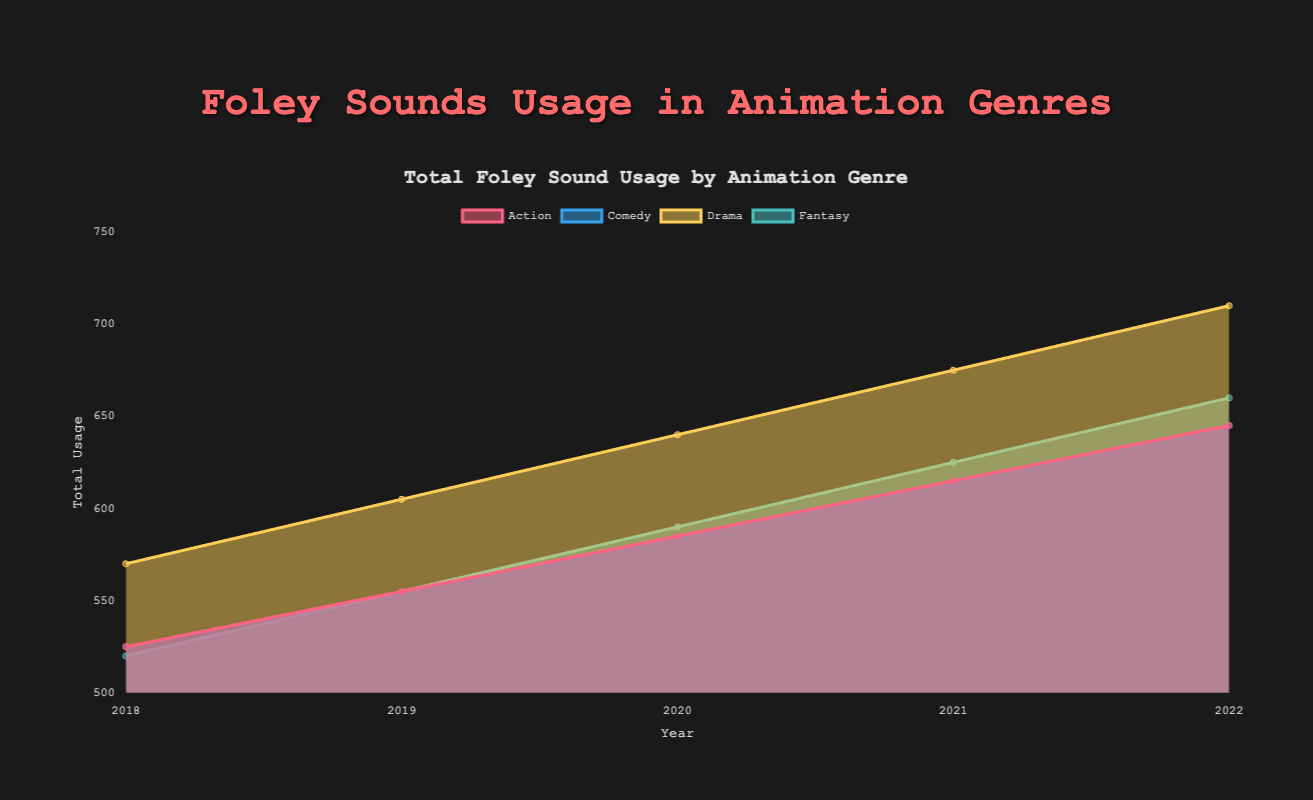What is the title of the chart? The title of the chart is clearly stated at the top in larger font size and bold text, which reads "Total Foley Sound Usage by Animation Genre."
Answer: Total Foley Sound Usage by Animation Genre Which genre’s Foley sound usage has the highest starting point in 2018? To find the highest starting point for 2018, look at the y-values for all genres at the year 2018. The highest starting point is for Drama, as it starts at 570.
Answer: Drama How many years are shown in the chart? The x-axis, which represents the years, has labels from 2018 to 2022, indicating five years.
Answer: 5 What is the general trend for Foley sound usage in the Comedy genre over the years? By following the line and area representing the Comedy genre from 2018 to 2022, you can observe that the usage is increasing in a linear fashion across all years.
Answer: Increasing Which genre saw the greatest increase in Foley sound usage from 2018 to 2022? To determine the greatest increase, subtract the 2018 value from the 2022 value for each genre and compare the differences. Drama increased from 570 to 710, which is the largest increase of 140.
Answer: Drama Is Foley sound usage in Fantasy higher or lower than in Comedy in the year 2020? By looking at the values for Fantasy and Comedy for the year 2020, Fantasy has a value of 590 and Comedy has a value of 585. Therefore, Foley sound usage in Fantasy is higher.
Answer: Higher What is the total Foley sound usage for Action, Comedy, and Drama in the year 2021? Sum the values for Action (615), Comedy (615), and Drama (675) for the year 2021: 615 + 615 + 675 = 1905.
Answer: 1905 Which genre had the least increase in Foley sound usage between 2020 and 2022? Calculate the difference between 2022 and 2020 for each genre. Fantasy increased from 590 to 660, i.e., 70. This is the smallest increase compared to other genres.
Answer: Fantasy 